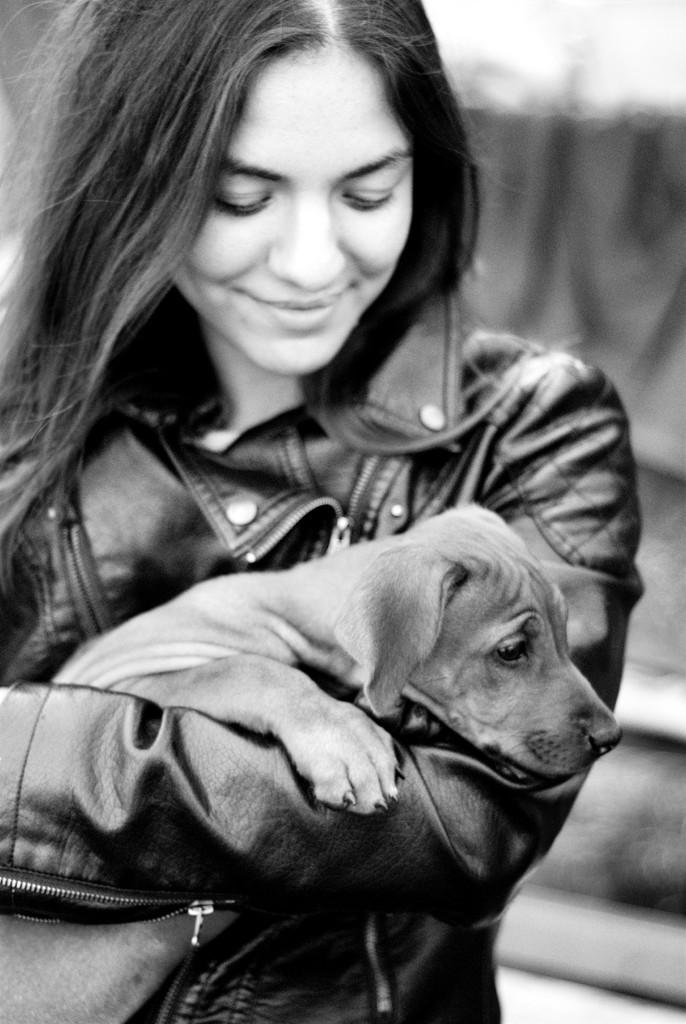Who is present in the image? There is a woman in the image. What is the woman doing in the image? The woman is standing and holding a dog. What is the woman's facial expression in the image? The woman is smiling in the image. What type of behavior can be observed in the birds in the image? There are no birds present in the image, so their behavior cannot be observed. 